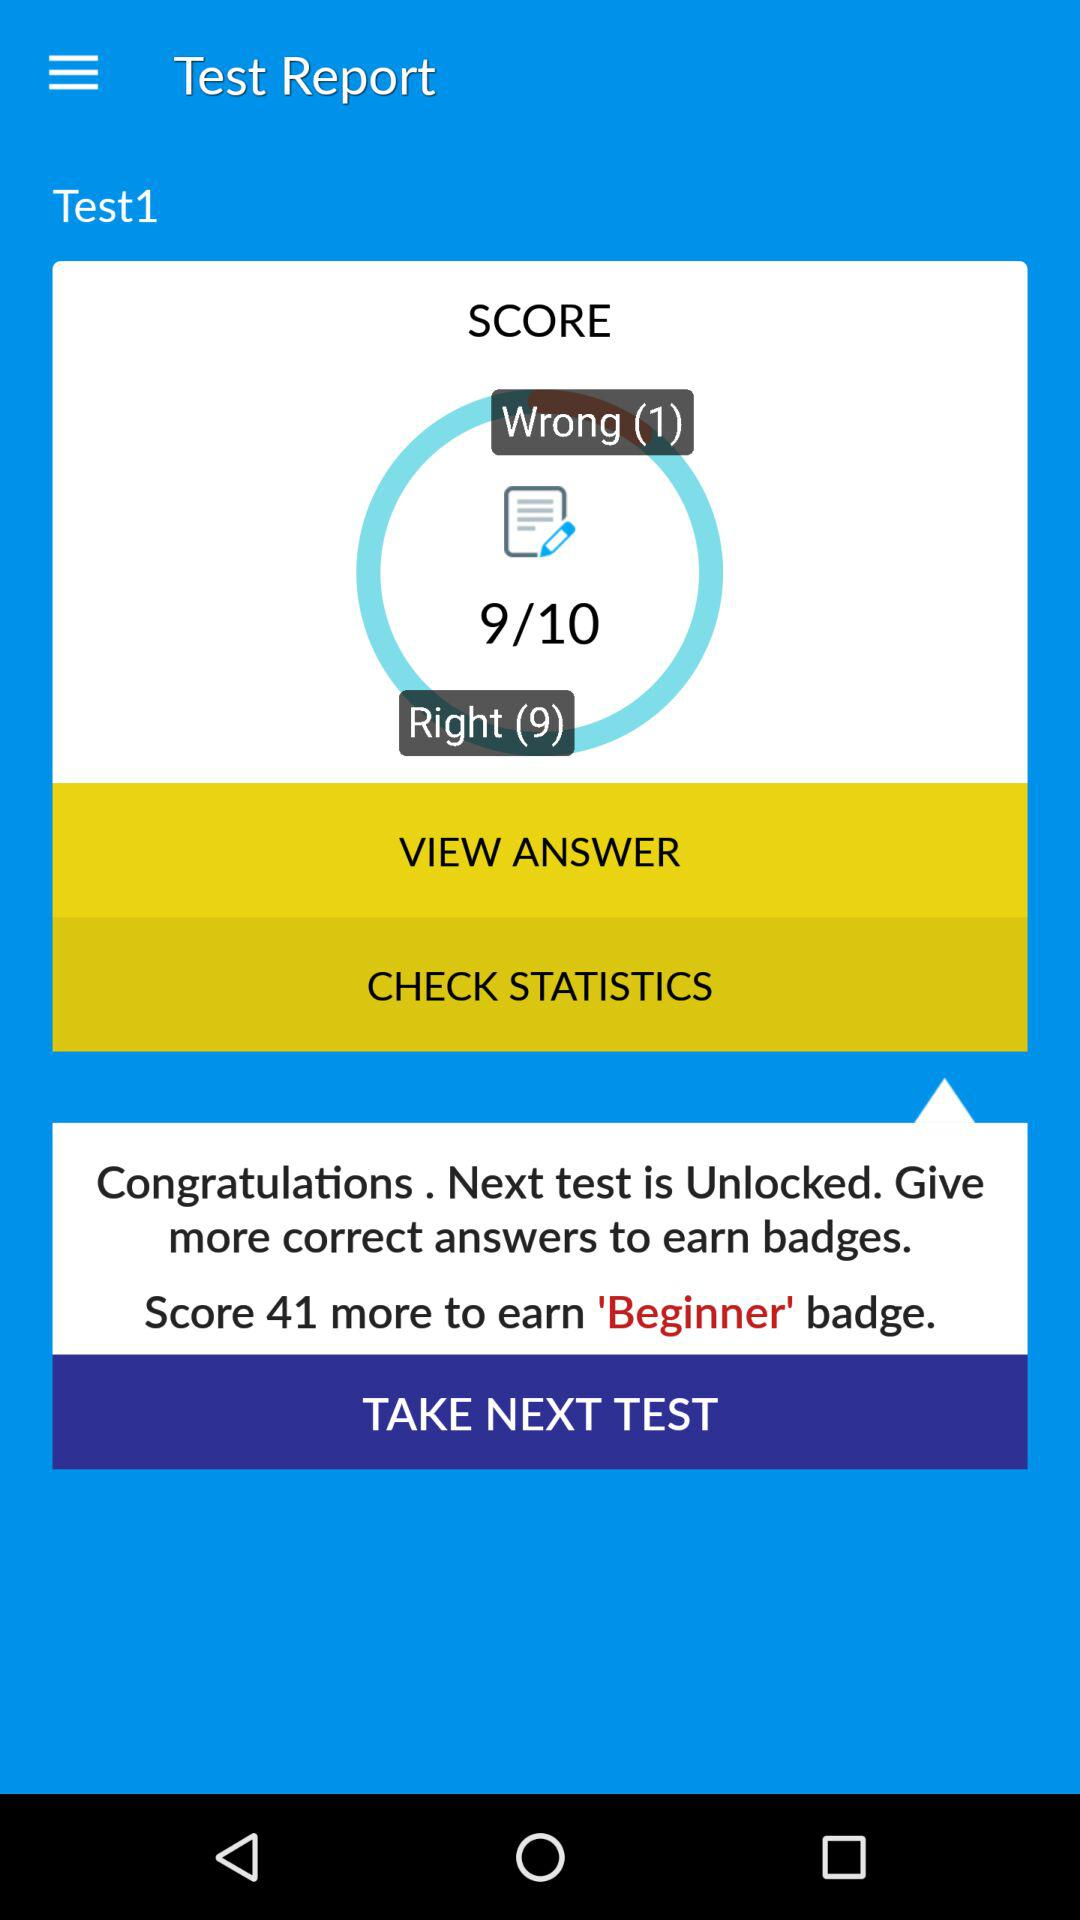How many more correct answers do I need to earn the 'Beginner' badge?
Answer the question using a single word or phrase. 41 